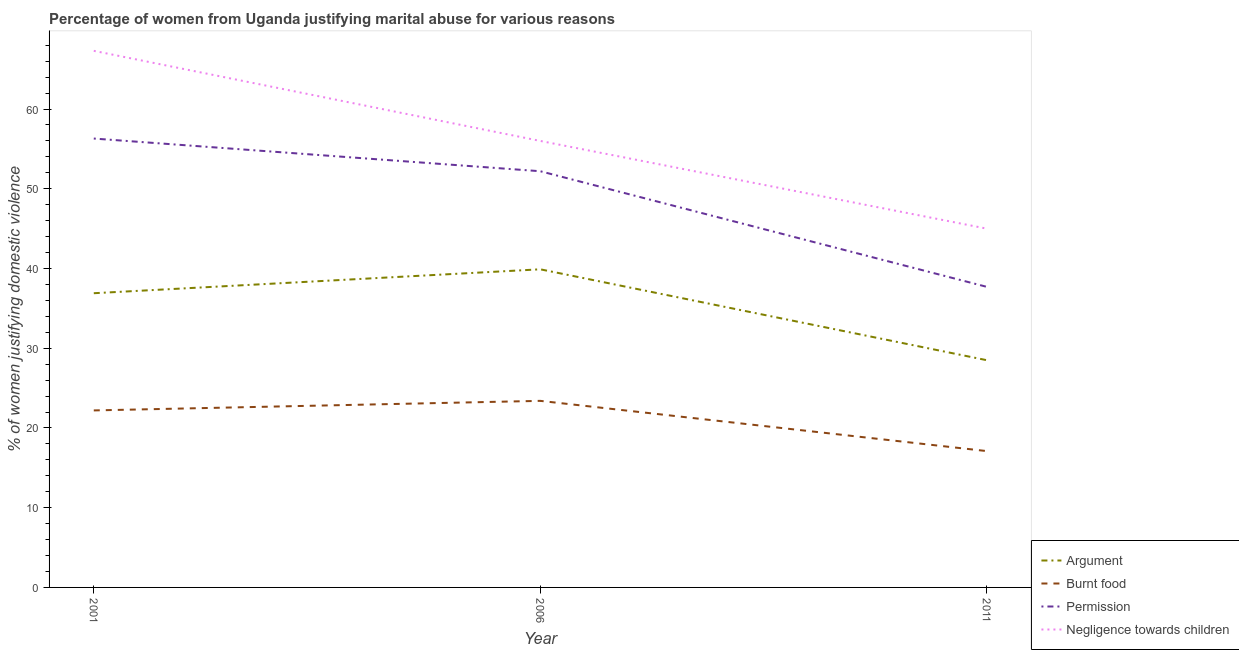Is the number of lines equal to the number of legend labels?
Your answer should be compact. Yes. Across all years, what is the maximum percentage of women justifying abuse in the case of an argument?
Make the answer very short. 39.9. Across all years, what is the minimum percentage of women justifying abuse for going without permission?
Your response must be concise. 37.7. In which year was the percentage of women justifying abuse for burning food maximum?
Offer a terse response. 2006. In which year was the percentage of women justifying abuse in the case of an argument minimum?
Ensure brevity in your answer.  2011. What is the total percentage of women justifying abuse in the case of an argument in the graph?
Offer a terse response. 105.3. What is the difference between the percentage of women justifying abuse for going without permission in 2001 and that in 2006?
Provide a short and direct response. 4.1. What is the difference between the percentage of women justifying abuse for showing negligence towards children in 2001 and the percentage of women justifying abuse for going without permission in 2006?
Your response must be concise. 15.1. What is the average percentage of women justifying abuse in the case of an argument per year?
Provide a short and direct response. 35.1. In the year 2011, what is the difference between the percentage of women justifying abuse for showing negligence towards children and percentage of women justifying abuse for going without permission?
Offer a terse response. 7.3. In how many years, is the percentage of women justifying abuse for going without permission greater than 58 %?
Your answer should be compact. 0. What is the ratio of the percentage of women justifying abuse for showing negligence towards children in 2006 to that in 2011?
Your response must be concise. 1.24. Is the difference between the percentage of women justifying abuse for going without permission in 2001 and 2011 greater than the difference between the percentage of women justifying abuse for burning food in 2001 and 2011?
Ensure brevity in your answer.  Yes. What is the difference between the highest and the second highest percentage of women justifying abuse for showing negligence towards children?
Offer a very short reply. 11.3. What is the difference between the highest and the lowest percentage of women justifying abuse for going without permission?
Provide a succinct answer. 18.6. In how many years, is the percentage of women justifying abuse for going without permission greater than the average percentage of women justifying abuse for going without permission taken over all years?
Provide a succinct answer. 2. Is the sum of the percentage of women justifying abuse for burning food in 2001 and 2006 greater than the maximum percentage of women justifying abuse for showing negligence towards children across all years?
Provide a short and direct response. No. Is it the case that in every year, the sum of the percentage of women justifying abuse for burning food and percentage of women justifying abuse in the case of an argument is greater than the sum of percentage of women justifying abuse for going without permission and percentage of women justifying abuse for showing negligence towards children?
Keep it short and to the point. Yes. Is it the case that in every year, the sum of the percentage of women justifying abuse in the case of an argument and percentage of women justifying abuse for burning food is greater than the percentage of women justifying abuse for going without permission?
Provide a succinct answer. Yes. Is the percentage of women justifying abuse for burning food strictly greater than the percentage of women justifying abuse in the case of an argument over the years?
Provide a short and direct response. No. How many years are there in the graph?
Give a very brief answer. 3. Does the graph contain grids?
Give a very brief answer. No. How many legend labels are there?
Give a very brief answer. 4. What is the title of the graph?
Offer a terse response. Percentage of women from Uganda justifying marital abuse for various reasons. Does "Oil" appear as one of the legend labels in the graph?
Your answer should be very brief. No. What is the label or title of the X-axis?
Offer a very short reply. Year. What is the label or title of the Y-axis?
Offer a terse response. % of women justifying domestic violence. What is the % of women justifying domestic violence in Argument in 2001?
Provide a short and direct response. 36.9. What is the % of women justifying domestic violence of Burnt food in 2001?
Offer a terse response. 22.2. What is the % of women justifying domestic violence in Permission in 2001?
Ensure brevity in your answer.  56.3. What is the % of women justifying domestic violence of Negligence towards children in 2001?
Give a very brief answer. 67.3. What is the % of women justifying domestic violence of Argument in 2006?
Your response must be concise. 39.9. What is the % of women justifying domestic violence of Burnt food in 2006?
Offer a terse response. 23.4. What is the % of women justifying domestic violence of Permission in 2006?
Ensure brevity in your answer.  52.2. What is the % of women justifying domestic violence of Burnt food in 2011?
Ensure brevity in your answer.  17.1. What is the % of women justifying domestic violence in Permission in 2011?
Ensure brevity in your answer.  37.7. What is the % of women justifying domestic violence of Negligence towards children in 2011?
Make the answer very short. 45. Across all years, what is the maximum % of women justifying domestic violence of Argument?
Your answer should be very brief. 39.9. Across all years, what is the maximum % of women justifying domestic violence of Burnt food?
Provide a short and direct response. 23.4. Across all years, what is the maximum % of women justifying domestic violence of Permission?
Make the answer very short. 56.3. Across all years, what is the maximum % of women justifying domestic violence in Negligence towards children?
Provide a short and direct response. 67.3. Across all years, what is the minimum % of women justifying domestic violence of Burnt food?
Make the answer very short. 17.1. Across all years, what is the minimum % of women justifying domestic violence in Permission?
Give a very brief answer. 37.7. Across all years, what is the minimum % of women justifying domestic violence of Negligence towards children?
Ensure brevity in your answer.  45. What is the total % of women justifying domestic violence of Argument in the graph?
Your response must be concise. 105.3. What is the total % of women justifying domestic violence of Burnt food in the graph?
Your response must be concise. 62.7. What is the total % of women justifying domestic violence in Permission in the graph?
Your answer should be very brief. 146.2. What is the total % of women justifying domestic violence in Negligence towards children in the graph?
Ensure brevity in your answer.  168.3. What is the difference between the % of women justifying domestic violence of Negligence towards children in 2001 and that in 2011?
Offer a very short reply. 22.3. What is the difference between the % of women justifying domestic violence of Permission in 2006 and that in 2011?
Provide a succinct answer. 14.5. What is the difference between the % of women justifying domestic violence in Negligence towards children in 2006 and that in 2011?
Your response must be concise. 11. What is the difference between the % of women justifying domestic violence of Argument in 2001 and the % of women justifying domestic violence of Burnt food in 2006?
Provide a succinct answer. 13.5. What is the difference between the % of women justifying domestic violence in Argument in 2001 and the % of women justifying domestic violence in Permission in 2006?
Offer a very short reply. -15.3. What is the difference between the % of women justifying domestic violence of Argument in 2001 and the % of women justifying domestic violence of Negligence towards children in 2006?
Your answer should be very brief. -19.1. What is the difference between the % of women justifying domestic violence of Burnt food in 2001 and the % of women justifying domestic violence of Negligence towards children in 2006?
Offer a terse response. -33.8. What is the difference between the % of women justifying domestic violence of Permission in 2001 and the % of women justifying domestic violence of Negligence towards children in 2006?
Offer a very short reply. 0.3. What is the difference between the % of women justifying domestic violence in Argument in 2001 and the % of women justifying domestic violence in Burnt food in 2011?
Your answer should be compact. 19.8. What is the difference between the % of women justifying domestic violence in Argument in 2001 and the % of women justifying domestic violence in Permission in 2011?
Make the answer very short. -0.8. What is the difference between the % of women justifying domestic violence in Burnt food in 2001 and the % of women justifying domestic violence in Permission in 2011?
Provide a short and direct response. -15.5. What is the difference between the % of women justifying domestic violence of Burnt food in 2001 and the % of women justifying domestic violence of Negligence towards children in 2011?
Offer a very short reply. -22.8. What is the difference between the % of women justifying domestic violence in Permission in 2001 and the % of women justifying domestic violence in Negligence towards children in 2011?
Offer a very short reply. 11.3. What is the difference between the % of women justifying domestic violence of Argument in 2006 and the % of women justifying domestic violence of Burnt food in 2011?
Make the answer very short. 22.8. What is the difference between the % of women justifying domestic violence in Argument in 2006 and the % of women justifying domestic violence in Permission in 2011?
Your answer should be compact. 2.2. What is the difference between the % of women justifying domestic violence in Burnt food in 2006 and the % of women justifying domestic violence in Permission in 2011?
Keep it short and to the point. -14.3. What is the difference between the % of women justifying domestic violence in Burnt food in 2006 and the % of women justifying domestic violence in Negligence towards children in 2011?
Make the answer very short. -21.6. What is the difference between the % of women justifying domestic violence in Permission in 2006 and the % of women justifying domestic violence in Negligence towards children in 2011?
Ensure brevity in your answer.  7.2. What is the average % of women justifying domestic violence in Argument per year?
Provide a short and direct response. 35.1. What is the average % of women justifying domestic violence in Burnt food per year?
Offer a terse response. 20.9. What is the average % of women justifying domestic violence of Permission per year?
Offer a terse response. 48.73. What is the average % of women justifying domestic violence of Negligence towards children per year?
Ensure brevity in your answer.  56.1. In the year 2001, what is the difference between the % of women justifying domestic violence of Argument and % of women justifying domestic violence of Burnt food?
Offer a terse response. 14.7. In the year 2001, what is the difference between the % of women justifying domestic violence in Argument and % of women justifying domestic violence in Permission?
Your answer should be compact. -19.4. In the year 2001, what is the difference between the % of women justifying domestic violence in Argument and % of women justifying domestic violence in Negligence towards children?
Keep it short and to the point. -30.4. In the year 2001, what is the difference between the % of women justifying domestic violence of Burnt food and % of women justifying domestic violence of Permission?
Give a very brief answer. -34.1. In the year 2001, what is the difference between the % of women justifying domestic violence of Burnt food and % of women justifying domestic violence of Negligence towards children?
Give a very brief answer. -45.1. In the year 2006, what is the difference between the % of women justifying domestic violence of Argument and % of women justifying domestic violence of Burnt food?
Give a very brief answer. 16.5. In the year 2006, what is the difference between the % of women justifying domestic violence of Argument and % of women justifying domestic violence of Negligence towards children?
Provide a short and direct response. -16.1. In the year 2006, what is the difference between the % of women justifying domestic violence in Burnt food and % of women justifying domestic violence in Permission?
Provide a short and direct response. -28.8. In the year 2006, what is the difference between the % of women justifying domestic violence of Burnt food and % of women justifying domestic violence of Negligence towards children?
Make the answer very short. -32.6. In the year 2006, what is the difference between the % of women justifying domestic violence of Permission and % of women justifying domestic violence of Negligence towards children?
Offer a terse response. -3.8. In the year 2011, what is the difference between the % of women justifying domestic violence of Argument and % of women justifying domestic violence of Burnt food?
Make the answer very short. 11.4. In the year 2011, what is the difference between the % of women justifying domestic violence in Argument and % of women justifying domestic violence in Negligence towards children?
Give a very brief answer. -16.5. In the year 2011, what is the difference between the % of women justifying domestic violence of Burnt food and % of women justifying domestic violence of Permission?
Give a very brief answer. -20.6. In the year 2011, what is the difference between the % of women justifying domestic violence of Burnt food and % of women justifying domestic violence of Negligence towards children?
Your answer should be very brief. -27.9. In the year 2011, what is the difference between the % of women justifying domestic violence of Permission and % of women justifying domestic violence of Negligence towards children?
Make the answer very short. -7.3. What is the ratio of the % of women justifying domestic violence of Argument in 2001 to that in 2006?
Provide a short and direct response. 0.92. What is the ratio of the % of women justifying domestic violence in Burnt food in 2001 to that in 2006?
Provide a succinct answer. 0.95. What is the ratio of the % of women justifying domestic violence of Permission in 2001 to that in 2006?
Your answer should be compact. 1.08. What is the ratio of the % of women justifying domestic violence of Negligence towards children in 2001 to that in 2006?
Offer a terse response. 1.2. What is the ratio of the % of women justifying domestic violence of Argument in 2001 to that in 2011?
Your answer should be compact. 1.29. What is the ratio of the % of women justifying domestic violence in Burnt food in 2001 to that in 2011?
Give a very brief answer. 1.3. What is the ratio of the % of women justifying domestic violence in Permission in 2001 to that in 2011?
Ensure brevity in your answer.  1.49. What is the ratio of the % of women justifying domestic violence of Negligence towards children in 2001 to that in 2011?
Offer a terse response. 1.5. What is the ratio of the % of women justifying domestic violence in Burnt food in 2006 to that in 2011?
Make the answer very short. 1.37. What is the ratio of the % of women justifying domestic violence of Permission in 2006 to that in 2011?
Provide a succinct answer. 1.38. What is the ratio of the % of women justifying domestic violence of Negligence towards children in 2006 to that in 2011?
Offer a very short reply. 1.24. What is the difference between the highest and the second highest % of women justifying domestic violence in Burnt food?
Give a very brief answer. 1.2. What is the difference between the highest and the lowest % of women justifying domestic violence of Burnt food?
Ensure brevity in your answer.  6.3. What is the difference between the highest and the lowest % of women justifying domestic violence of Permission?
Your answer should be compact. 18.6. What is the difference between the highest and the lowest % of women justifying domestic violence of Negligence towards children?
Provide a short and direct response. 22.3. 